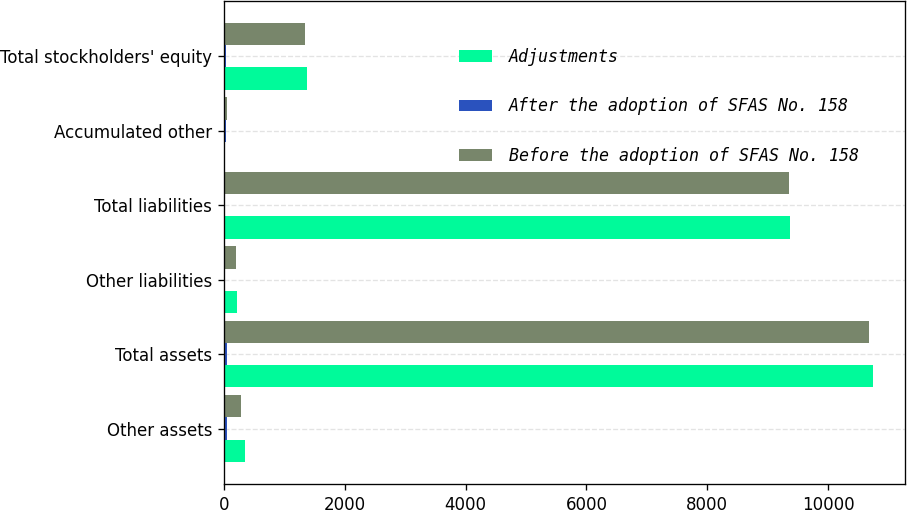Convert chart. <chart><loc_0><loc_0><loc_500><loc_500><stacked_bar_chart><ecel><fcel>Other assets<fcel>Total assets<fcel>Other liabilities<fcel>Total liabilities<fcel>Accumulated other<fcel>Total stockholders' equity<nl><fcel>Adjustments<fcel>344.9<fcel>10743.2<fcel>211.7<fcel>9363.7<fcel>8<fcel>1379.5<nl><fcel>After the adoption of SFAS No. 158<fcel>56.3<fcel>56.3<fcel>16.3<fcel>16.3<fcel>40<fcel>40<nl><fcel>Before the adoption of SFAS No. 158<fcel>288.6<fcel>10686.9<fcel>195.4<fcel>9347.4<fcel>48<fcel>1339.5<nl></chart> 